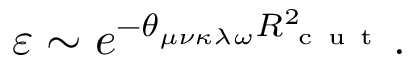Convert formula to latex. <formula><loc_0><loc_0><loc_500><loc_500>\varepsilon \sim e ^ { - \theta _ { \mu \nu \kappa \lambda \omega } R _ { c u t } ^ { 2 } } .</formula> 